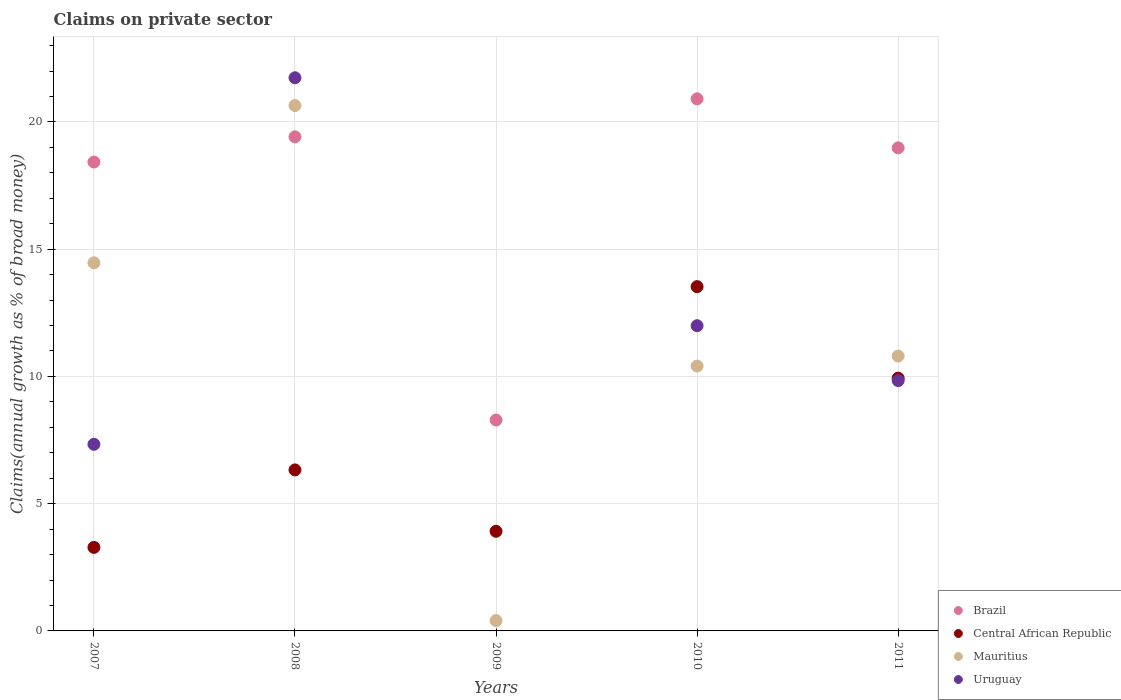Is the number of dotlines equal to the number of legend labels?
Offer a terse response. No. What is the percentage of broad money claimed on private sector in Uruguay in 2008?
Provide a short and direct response. 21.74. Across all years, what is the maximum percentage of broad money claimed on private sector in Mauritius?
Your response must be concise. 20.65. Across all years, what is the minimum percentage of broad money claimed on private sector in Brazil?
Provide a short and direct response. 8.29. In which year was the percentage of broad money claimed on private sector in Central African Republic maximum?
Provide a succinct answer. 2010. What is the total percentage of broad money claimed on private sector in Central African Republic in the graph?
Your response must be concise. 36.99. What is the difference between the percentage of broad money claimed on private sector in Uruguay in 2008 and that in 2010?
Offer a terse response. 9.74. What is the difference between the percentage of broad money claimed on private sector in Brazil in 2011 and the percentage of broad money claimed on private sector in Mauritius in 2007?
Provide a succinct answer. 4.52. What is the average percentage of broad money claimed on private sector in Brazil per year?
Your response must be concise. 17.2. In the year 2008, what is the difference between the percentage of broad money claimed on private sector in Uruguay and percentage of broad money claimed on private sector in Brazil?
Ensure brevity in your answer.  2.32. In how many years, is the percentage of broad money claimed on private sector in Uruguay greater than 20 %?
Offer a terse response. 1. What is the ratio of the percentage of broad money claimed on private sector in Mauritius in 2008 to that in 2011?
Keep it short and to the point. 1.91. Is the percentage of broad money claimed on private sector in Brazil in 2010 less than that in 2011?
Offer a very short reply. No. Is the difference between the percentage of broad money claimed on private sector in Uruguay in 2007 and 2010 greater than the difference between the percentage of broad money claimed on private sector in Brazil in 2007 and 2010?
Offer a terse response. No. What is the difference between the highest and the second highest percentage of broad money claimed on private sector in Central African Republic?
Your answer should be very brief. 3.6. What is the difference between the highest and the lowest percentage of broad money claimed on private sector in Mauritius?
Ensure brevity in your answer.  20.24. Is it the case that in every year, the sum of the percentage of broad money claimed on private sector in Uruguay and percentage of broad money claimed on private sector in Central African Republic  is greater than the sum of percentage of broad money claimed on private sector in Mauritius and percentage of broad money claimed on private sector in Brazil?
Ensure brevity in your answer.  No. Is it the case that in every year, the sum of the percentage of broad money claimed on private sector in Uruguay and percentage of broad money claimed on private sector in Mauritius  is greater than the percentage of broad money claimed on private sector in Central African Republic?
Offer a terse response. No. Is the percentage of broad money claimed on private sector in Mauritius strictly less than the percentage of broad money claimed on private sector in Central African Republic over the years?
Make the answer very short. No. How many years are there in the graph?
Provide a short and direct response. 5. What is the difference between two consecutive major ticks on the Y-axis?
Keep it short and to the point. 5. Where does the legend appear in the graph?
Provide a short and direct response. Bottom right. What is the title of the graph?
Give a very brief answer. Claims on private sector. Does "Ukraine" appear as one of the legend labels in the graph?
Offer a very short reply. No. What is the label or title of the Y-axis?
Offer a terse response. Claims(annual growth as % of broad money). What is the Claims(annual growth as % of broad money) in Brazil in 2007?
Your answer should be very brief. 18.43. What is the Claims(annual growth as % of broad money) of Central African Republic in 2007?
Your response must be concise. 3.28. What is the Claims(annual growth as % of broad money) of Mauritius in 2007?
Provide a succinct answer. 14.47. What is the Claims(annual growth as % of broad money) of Uruguay in 2007?
Your answer should be very brief. 7.33. What is the Claims(annual growth as % of broad money) of Brazil in 2008?
Your response must be concise. 19.42. What is the Claims(annual growth as % of broad money) of Central African Republic in 2008?
Provide a succinct answer. 6.33. What is the Claims(annual growth as % of broad money) in Mauritius in 2008?
Keep it short and to the point. 20.65. What is the Claims(annual growth as % of broad money) in Uruguay in 2008?
Your response must be concise. 21.74. What is the Claims(annual growth as % of broad money) of Brazil in 2009?
Your answer should be compact. 8.29. What is the Claims(annual growth as % of broad money) in Central African Republic in 2009?
Your answer should be compact. 3.91. What is the Claims(annual growth as % of broad money) of Mauritius in 2009?
Offer a terse response. 0.41. What is the Claims(annual growth as % of broad money) of Uruguay in 2009?
Provide a succinct answer. 0. What is the Claims(annual growth as % of broad money) of Brazil in 2010?
Your answer should be compact. 20.91. What is the Claims(annual growth as % of broad money) in Central African Republic in 2010?
Give a very brief answer. 13.53. What is the Claims(annual growth as % of broad money) in Mauritius in 2010?
Give a very brief answer. 10.41. What is the Claims(annual growth as % of broad money) in Uruguay in 2010?
Your response must be concise. 11.99. What is the Claims(annual growth as % of broad money) of Brazil in 2011?
Your answer should be very brief. 18.98. What is the Claims(annual growth as % of broad money) of Central African Republic in 2011?
Ensure brevity in your answer.  9.93. What is the Claims(annual growth as % of broad money) in Mauritius in 2011?
Make the answer very short. 10.8. What is the Claims(annual growth as % of broad money) in Uruguay in 2011?
Make the answer very short. 9.84. Across all years, what is the maximum Claims(annual growth as % of broad money) in Brazil?
Make the answer very short. 20.91. Across all years, what is the maximum Claims(annual growth as % of broad money) in Central African Republic?
Ensure brevity in your answer.  13.53. Across all years, what is the maximum Claims(annual growth as % of broad money) of Mauritius?
Provide a succinct answer. 20.65. Across all years, what is the maximum Claims(annual growth as % of broad money) in Uruguay?
Ensure brevity in your answer.  21.74. Across all years, what is the minimum Claims(annual growth as % of broad money) in Brazil?
Keep it short and to the point. 8.29. Across all years, what is the minimum Claims(annual growth as % of broad money) in Central African Republic?
Offer a very short reply. 3.28. Across all years, what is the minimum Claims(annual growth as % of broad money) of Mauritius?
Ensure brevity in your answer.  0.41. What is the total Claims(annual growth as % of broad money) of Brazil in the graph?
Make the answer very short. 86.02. What is the total Claims(annual growth as % of broad money) in Central African Republic in the graph?
Your answer should be compact. 36.99. What is the total Claims(annual growth as % of broad money) of Mauritius in the graph?
Provide a short and direct response. 56.73. What is the total Claims(annual growth as % of broad money) in Uruguay in the graph?
Provide a short and direct response. 50.9. What is the difference between the Claims(annual growth as % of broad money) of Brazil in 2007 and that in 2008?
Provide a succinct answer. -0.99. What is the difference between the Claims(annual growth as % of broad money) of Central African Republic in 2007 and that in 2008?
Your answer should be compact. -3.04. What is the difference between the Claims(annual growth as % of broad money) of Mauritius in 2007 and that in 2008?
Provide a succinct answer. -6.18. What is the difference between the Claims(annual growth as % of broad money) of Uruguay in 2007 and that in 2008?
Provide a short and direct response. -14.4. What is the difference between the Claims(annual growth as % of broad money) of Brazil in 2007 and that in 2009?
Offer a terse response. 10.14. What is the difference between the Claims(annual growth as % of broad money) of Central African Republic in 2007 and that in 2009?
Keep it short and to the point. -0.63. What is the difference between the Claims(annual growth as % of broad money) of Mauritius in 2007 and that in 2009?
Provide a succinct answer. 14.06. What is the difference between the Claims(annual growth as % of broad money) in Brazil in 2007 and that in 2010?
Offer a very short reply. -2.48. What is the difference between the Claims(annual growth as % of broad money) of Central African Republic in 2007 and that in 2010?
Give a very brief answer. -10.25. What is the difference between the Claims(annual growth as % of broad money) of Mauritius in 2007 and that in 2010?
Give a very brief answer. 4.06. What is the difference between the Claims(annual growth as % of broad money) of Uruguay in 2007 and that in 2010?
Keep it short and to the point. -4.66. What is the difference between the Claims(annual growth as % of broad money) in Brazil in 2007 and that in 2011?
Your answer should be compact. -0.56. What is the difference between the Claims(annual growth as % of broad money) in Central African Republic in 2007 and that in 2011?
Ensure brevity in your answer.  -6.65. What is the difference between the Claims(annual growth as % of broad money) of Mauritius in 2007 and that in 2011?
Your response must be concise. 3.67. What is the difference between the Claims(annual growth as % of broad money) in Uruguay in 2007 and that in 2011?
Your response must be concise. -2.5. What is the difference between the Claims(annual growth as % of broad money) of Brazil in 2008 and that in 2009?
Keep it short and to the point. 11.13. What is the difference between the Claims(annual growth as % of broad money) of Central African Republic in 2008 and that in 2009?
Provide a succinct answer. 2.41. What is the difference between the Claims(annual growth as % of broad money) of Mauritius in 2008 and that in 2009?
Your response must be concise. 20.24. What is the difference between the Claims(annual growth as % of broad money) of Brazil in 2008 and that in 2010?
Offer a terse response. -1.49. What is the difference between the Claims(annual growth as % of broad money) of Central African Republic in 2008 and that in 2010?
Your answer should be very brief. -7.2. What is the difference between the Claims(annual growth as % of broad money) in Mauritius in 2008 and that in 2010?
Keep it short and to the point. 10.24. What is the difference between the Claims(annual growth as % of broad money) of Uruguay in 2008 and that in 2010?
Offer a terse response. 9.74. What is the difference between the Claims(annual growth as % of broad money) of Brazil in 2008 and that in 2011?
Ensure brevity in your answer.  0.43. What is the difference between the Claims(annual growth as % of broad money) in Central African Republic in 2008 and that in 2011?
Your response must be concise. -3.61. What is the difference between the Claims(annual growth as % of broad money) in Mauritius in 2008 and that in 2011?
Make the answer very short. 9.84. What is the difference between the Claims(annual growth as % of broad money) of Uruguay in 2008 and that in 2011?
Offer a very short reply. 11.9. What is the difference between the Claims(annual growth as % of broad money) of Brazil in 2009 and that in 2010?
Ensure brevity in your answer.  -12.62. What is the difference between the Claims(annual growth as % of broad money) of Central African Republic in 2009 and that in 2010?
Provide a short and direct response. -9.61. What is the difference between the Claims(annual growth as % of broad money) of Mauritius in 2009 and that in 2010?
Your response must be concise. -10. What is the difference between the Claims(annual growth as % of broad money) in Brazil in 2009 and that in 2011?
Give a very brief answer. -10.69. What is the difference between the Claims(annual growth as % of broad money) of Central African Republic in 2009 and that in 2011?
Make the answer very short. -6.02. What is the difference between the Claims(annual growth as % of broad money) of Mauritius in 2009 and that in 2011?
Provide a succinct answer. -10.39. What is the difference between the Claims(annual growth as % of broad money) of Brazil in 2010 and that in 2011?
Keep it short and to the point. 1.93. What is the difference between the Claims(annual growth as % of broad money) of Central African Republic in 2010 and that in 2011?
Provide a short and direct response. 3.6. What is the difference between the Claims(annual growth as % of broad money) of Mauritius in 2010 and that in 2011?
Offer a terse response. -0.39. What is the difference between the Claims(annual growth as % of broad money) of Uruguay in 2010 and that in 2011?
Offer a very short reply. 2.16. What is the difference between the Claims(annual growth as % of broad money) in Brazil in 2007 and the Claims(annual growth as % of broad money) in Central African Republic in 2008?
Your response must be concise. 12.1. What is the difference between the Claims(annual growth as % of broad money) in Brazil in 2007 and the Claims(annual growth as % of broad money) in Mauritius in 2008?
Make the answer very short. -2.22. What is the difference between the Claims(annual growth as % of broad money) in Brazil in 2007 and the Claims(annual growth as % of broad money) in Uruguay in 2008?
Ensure brevity in your answer.  -3.31. What is the difference between the Claims(annual growth as % of broad money) in Central African Republic in 2007 and the Claims(annual growth as % of broad money) in Mauritius in 2008?
Your answer should be very brief. -17.36. What is the difference between the Claims(annual growth as % of broad money) of Central African Republic in 2007 and the Claims(annual growth as % of broad money) of Uruguay in 2008?
Keep it short and to the point. -18.45. What is the difference between the Claims(annual growth as % of broad money) of Mauritius in 2007 and the Claims(annual growth as % of broad money) of Uruguay in 2008?
Your answer should be very brief. -7.27. What is the difference between the Claims(annual growth as % of broad money) in Brazil in 2007 and the Claims(annual growth as % of broad money) in Central African Republic in 2009?
Keep it short and to the point. 14.51. What is the difference between the Claims(annual growth as % of broad money) of Brazil in 2007 and the Claims(annual growth as % of broad money) of Mauritius in 2009?
Your answer should be very brief. 18.02. What is the difference between the Claims(annual growth as % of broad money) in Central African Republic in 2007 and the Claims(annual growth as % of broad money) in Mauritius in 2009?
Offer a terse response. 2.88. What is the difference between the Claims(annual growth as % of broad money) in Brazil in 2007 and the Claims(annual growth as % of broad money) in Central African Republic in 2010?
Offer a terse response. 4.9. What is the difference between the Claims(annual growth as % of broad money) in Brazil in 2007 and the Claims(annual growth as % of broad money) in Mauritius in 2010?
Offer a terse response. 8.02. What is the difference between the Claims(annual growth as % of broad money) of Brazil in 2007 and the Claims(annual growth as % of broad money) of Uruguay in 2010?
Offer a terse response. 6.43. What is the difference between the Claims(annual growth as % of broad money) of Central African Republic in 2007 and the Claims(annual growth as % of broad money) of Mauritius in 2010?
Provide a short and direct response. -7.12. What is the difference between the Claims(annual growth as % of broad money) of Central African Republic in 2007 and the Claims(annual growth as % of broad money) of Uruguay in 2010?
Provide a short and direct response. -8.71. What is the difference between the Claims(annual growth as % of broad money) in Mauritius in 2007 and the Claims(annual growth as % of broad money) in Uruguay in 2010?
Provide a succinct answer. 2.47. What is the difference between the Claims(annual growth as % of broad money) in Brazil in 2007 and the Claims(annual growth as % of broad money) in Central African Republic in 2011?
Provide a short and direct response. 8.49. What is the difference between the Claims(annual growth as % of broad money) of Brazil in 2007 and the Claims(annual growth as % of broad money) of Mauritius in 2011?
Keep it short and to the point. 7.62. What is the difference between the Claims(annual growth as % of broad money) in Brazil in 2007 and the Claims(annual growth as % of broad money) in Uruguay in 2011?
Offer a terse response. 8.59. What is the difference between the Claims(annual growth as % of broad money) in Central African Republic in 2007 and the Claims(annual growth as % of broad money) in Mauritius in 2011?
Make the answer very short. -7.52. What is the difference between the Claims(annual growth as % of broad money) in Central African Republic in 2007 and the Claims(annual growth as % of broad money) in Uruguay in 2011?
Your answer should be compact. -6.55. What is the difference between the Claims(annual growth as % of broad money) of Mauritius in 2007 and the Claims(annual growth as % of broad money) of Uruguay in 2011?
Your response must be concise. 4.63. What is the difference between the Claims(annual growth as % of broad money) of Brazil in 2008 and the Claims(annual growth as % of broad money) of Central African Republic in 2009?
Your response must be concise. 15.5. What is the difference between the Claims(annual growth as % of broad money) in Brazil in 2008 and the Claims(annual growth as % of broad money) in Mauritius in 2009?
Your answer should be compact. 19.01. What is the difference between the Claims(annual growth as % of broad money) of Central African Republic in 2008 and the Claims(annual growth as % of broad money) of Mauritius in 2009?
Offer a terse response. 5.92. What is the difference between the Claims(annual growth as % of broad money) in Brazil in 2008 and the Claims(annual growth as % of broad money) in Central African Republic in 2010?
Offer a terse response. 5.89. What is the difference between the Claims(annual growth as % of broad money) in Brazil in 2008 and the Claims(annual growth as % of broad money) in Mauritius in 2010?
Your answer should be very brief. 9.01. What is the difference between the Claims(annual growth as % of broad money) of Brazil in 2008 and the Claims(annual growth as % of broad money) of Uruguay in 2010?
Ensure brevity in your answer.  7.42. What is the difference between the Claims(annual growth as % of broad money) in Central African Republic in 2008 and the Claims(annual growth as % of broad money) in Mauritius in 2010?
Offer a terse response. -4.08. What is the difference between the Claims(annual growth as % of broad money) in Central African Republic in 2008 and the Claims(annual growth as % of broad money) in Uruguay in 2010?
Your response must be concise. -5.67. What is the difference between the Claims(annual growth as % of broad money) of Mauritius in 2008 and the Claims(annual growth as % of broad money) of Uruguay in 2010?
Offer a very short reply. 8.65. What is the difference between the Claims(annual growth as % of broad money) in Brazil in 2008 and the Claims(annual growth as % of broad money) in Central African Republic in 2011?
Offer a terse response. 9.48. What is the difference between the Claims(annual growth as % of broad money) in Brazil in 2008 and the Claims(annual growth as % of broad money) in Mauritius in 2011?
Make the answer very short. 8.62. What is the difference between the Claims(annual growth as % of broad money) in Brazil in 2008 and the Claims(annual growth as % of broad money) in Uruguay in 2011?
Offer a very short reply. 9.58. What is the difference between the Claims(annual growth as % of broad money) in Central African Republic in 2008 and the Claims(annual growth as % of broad money) in Mauritius in 2011?
Make the answer very short. -4.47. What is the difference between the Claims(annual growth as % of broad money) of Central African Republic in 2008 and the Claims(annual growth as % of broad money) of Uruguay in 2011?
Offer a very short reply. -3.51. What is the difference between the Claims(annual growth as % of broad money) of Mauritius in 2008 and the Claims(annual growth as % of broad money) of Uruguay in 2011?
Your answer should be compact. 10.81. What is the difference between the Claims(annual growth as % of broad money) in Brazil in 2009 and the Claims(annual growth as % of broad money) in Central African Republic in 2010?
Ensure brevity in your answer.  -5.24. What is the difference between the Claims(annual growth as % of broad money) in Brazil in 2009 and the Claims(annual growth as % of broad money) in Mauritius in 2010?
Offer a very short reply. -2.12. What is the difference between the Claims(annual growth as % of broad money) of Brazil in 2009 and the Claims(annual growth as % of broad money) of Uruguay in 2010?
Your answer should be very brief. -3.71. What is the difference between the Claims(annual growth as % of broad money) in Central African Republic in 2009 and the Claims(annual growth as % of broad money) in Mauritius in 2010?
Give a very brief answer. -6.49. What is the difference between the Claims(annual growth as % of broad money) in Central African Republic in 2009 and the Claims(annual growth as % of broad money) in Uruguay in 2010?
Your answer should be compact. -8.08. What is the difference between the Claims(annual growth as % of broad money) in Mauritius in 2009 and the Claims(annual growth as % of broad money) in Uruguay in 2010?
Your answer should be compact. -11.59. What is the difference between the Claims(annual growth as % of broad money) of Brazil in 2009 and the Claims(annual growth as % of broad money) of Central African Republic in 2011?
Provide a succinct answer. -1.65. What is the difference between the Claims(annual growth as % of broad money) in Brazil in 2009 and the Claims(annual growth as % of broad money) in Mauritius in 2011?
Your answer should be compact. -2.51. What is the difference between the Claims(annual growth as % of broad money) in Brazil in 2009 and the Claims(annual growth as % of broad money) in Uruguay in 2011?
Make the answer very short. -1.55. What is the difference between the Claims(annual growth as % of broad money) of Central African Republic in 2009 and the Claims(annual growth as % of broad money) of Mauritius in 2011?
Offer a very short reply. -6.89. What is the difference between the Claims(annual growth as % of broad money) in Central African Republic in 2009 and the Claims(annual growth as % of broad money) in Uruguay in 2011?
Provide a succinct answer. -5.92. What is the difference between the Claims(annual growth as % of broad money) in Mauritius in 2009 and the Claims(annual growth as % of broad money) in Uruguay in 2011?
Your answer should be compact. -9.43. What is the difference between the Claims(annual growth as % of broad money) of Brazil in 2010 and the Claims(annual growth as % of broad money) of Central African Republic in 2011?
Your answer should be compact. 10.98. What is the difference between the Claims(annual growth as % of broad money) of Brazil in 2010 and the Claims(annual growth as % of broad money) of Mauritius in 2011?
Ensure brevity in your answer.  10.11. What is the difference between the Claims(annual growth as % of broad money) of Brazil in 2010 and the Claims(annual growth as % of broad money) of Uruguay in 2011?
Offer a terse response. 11.07. What is the difference between the Claims(annual growth as % of broad money) of Central African Republic in 2010 and the Claims(annual growth as % of broad money) of Mauritius in 2011?
Provide a short and direct response. 2.73. What is the difference between the Claims(annual growth as % of broad money) of Central African Republic in 2010 and the Claims(annual growth as % of broad money) of Uruguay in 2011?
Provide a succinct answer. 3.69. What is the difference between the Claims(annual growth as % of broad money) in Mauritius in 2010 and the Claims(annual growth as % of broad money) in Uruguay in 2011?
Make the answer very short. 0.57. What is the average Claims(annual growth as % of broad money) of Brazil per year?
Your answer should be compact. 17.2. What is the average Claims(annual growth as % of broad money) of Central African Republic per year?
Keep it short and to the point. 7.4. What is the average Claims(annual growth as % of broad money) of Mauritius per year?
Keep it short and to the point. 11.35. What is the average Claims(annual growth as % of broad money) in Uruguay per year?
Ensure brevity in your answer.  10.18. In the year 2007, what is the difference between the Claims(annual growth as % of broad money) in Brazil and Claims(annual growth as % of broad money) in Central African Republic?
Make the answer very short. 15.14. In the year 2007, what is the difference between the Claims(annual growth as % of broad money) of Brazil and Claims(annual growth as % of broad money) of Mauritius?
Provide a short and direct response. 3.96. In the year 2007, what is the difference between the Claims(annual growth as % of broad money) of Brazil and Claims(annual growth as % of broad money) of Uruguay?
Your response must be concise. 11.09. In the year 2007, what is the difference between the Claims(annual growth as % of broad money) of Central African Republic and Claims(annual growth as % of broad money) of Mauritius?
Keep it short and to the point. -11.18. In the year 2007, what is the difference between the Claims(annual growth as % of broad money) in Central African Republic and Claims(annual growth as % of broad money) in Uruguay?
Make the answer very short. -4.05. In the year 2007, what is the difference between the Claims(annual growth as % of broad money) of Mauritius and Claims(annual growth as % of broad money) of Uruguay?
Provide a succinct answer. 7.13. In the year 2008, what is the difference between the Claims(annual growth as % of broad money) in Brazil and Claims(annual growth as % of broad money) in Central African Republic?
Offer a very short reply. 13.09. In the year 2008, what is the difference between the Claims(annual growth as % of broad money) in Brazil and Claims(annual growth as % of broad money) in Mauritius?
Provide a short and direct response. -1.23. In the year 2008, what is the difference between the Claims(annual growth as % of broad money) in Brazil and Claims(annual growth as % of broad money) in Uruguay?
Ensure brevity in your answer.  -2.32. In the year 2008, what is the difference between the Claims(annual growth as % of broad money) of Central African Republic and Claims(annual growth as % of broad money) of Mauritius?
Give a very brief answer. -14.32. In the year 2008, what is the difference between the Claims(annual growth as % of broad money) in Central African Republic and Claims(annual growth as % of broad money) in Uruguay?
Your response must be concise. -15.41. In the year 2008, what is the difference between the Claims(annual growth as % of broad money) in Mauritius and Claims(annual growth as % of broad money) in Uruguay?
Offer a terse response. -1.09. In the year 2009, what is the difference between the Claims(annual growth as % of broad money) of Brazil and Claims(annual growth as % of broad money) of Central African Republic?
Give a very brief answer. 4.37. In the year 2009, what is the difference between the Claims(annual growth as % of broad money) of Brazil and Claims(annual growth as % of broad money) of Mauritius?
Ensure brevity in your answer.  7.88. In the year 2009, what is the difference between the Claims(annual growth as % of broad money) in Central African Republic and Claims(annual growth as % of broad money) in Mauritius?
Your response must be concise. 3.51. In the year 2010, what is the difference between the Claims(annual growth as % of broad money) of Brazil and Claims(annual growth as % of broad money) of Central African Republic?
Provide a short and direct response. 7.38. In the year 2010, what is the difference between the Claims(annual growth as % of broad money) in Brazil and Claims(annual growth as % of broad money) in Mauritius?
Ensure brevity in your answer.  10.5. In the year 2010, what is the difference between the Claims(annual growth as % of broad money) of Brazil and Claims(annual growth as % of broad money) of Uruguay?
Provide a succinct answer. 8.92. In the year 2010, what is the difference between the Claims(annual growth as % of broad money) of Central African Republic and Claims(annual growth as % of broad money) of Mauritius?
Provide a succinct answer. 3.12. In the year 2010, what is the difference between the Claims(annual growth as % of broad money) of Central African Republic and Claims(annual growth as % of broad money) of Uruguay?
Offer a very short reply. 1.54. In the year 2010, what is the difference between the Claims(annual growth as % of broad money) in Mauritius and Claims(annual growth as % of broad money) in Uruguay?
Provide a short and direct response. -1.58. In the year 2011, what is the difference between the Claims(annual growth as % of broad money) of Brazil and Claims(annual growth as % of broad money) of Central African Republic?
Offer a very short reply. 9.05. In the year 2011, what is the difference between the Claims(annual growth as % of broad money) in Brazil and Claims(annual growth as % of broad money) in Mauritius?
Provide a succinct answer. 8.18. In the year 2011, what is the difference between the Claims(annual growth as % of broad money) in Brazil and Claims(annual growth as % of broad money) in Uruguay?
Your answer should be very brief. 9.14. In the year 2011, what is the difference between the Claims(annual growth as % of broad money) of Central African Republic and Claims(annual growth as % of broad money) of Mauritius?
Keep it short and to the point. -0.87. In the year 2011, what is the difference between the Claims(annual growth as % of broad money) in Central African Republic and Claims(annual growth as % of broad money) in Uruguay?
Ensure brevity in your answer.  0.1. In the year 2011, what is the difference between the Claims(annual growth as % of broad money) in Mauritius and Claims(annual growth as % of broad money) in Uruguay?
Your answer should be compact. 0.96. What is the ratio of the Claims(annual growth as % of broad money) of Brazil in 2007 to that in 2008?
Offer a very short reply. 0.95. What is the ratio of the Claims(annual growth as % of broad money) in Central African Republic in 2007 to that in 2008?
Keep it short and to the point. 0.52. What is the ratio of the Claims(annual growth as % of broad money) of Mauritius in 2007 to that in 2008?
Provide a succinct answer. 0.7. What is the ratio of the Claims(annual growth as % of broad money) of Uruguay in 2007 to that in 2008?
Your answer should be compact. 0.34. What is the ratio of the Claims(annual growth as % of broad money) of Brazil in 2007 to that in 2009?
Your answer should be very brief. 2.22. What is the ratio of the Claims(annual growth as % of broad money) in Central African Republic in 2007 to that in 2009?
Ensure brevity in your answer.  0.84. What is the ratio of the Claims(annual growth as % of broad money) in Mauritius in 2007 to that in 2009?
Provide a short and direct response. 35.58. What is the ratio of the Claims(annual growth as % of broad money) in Brazil in 2007 to that in 2010?
Keep it short and to the point. 0.88. What is the ratio of the Claims(annual growth as % of broad money) in Central African Republic in 2007 to that in 2010?
Ensure brevity in your answer.  0.24. What is the ratio of the Claims(annual growth as % of broad money) of Mauritius in 2007 to that in 2010?
Your answer should be very brief. 1.39. What is the ratio of the Claims(annual growth as % of broad money) in Uruguay in 2007 to that in 2010?
Offer a very short reply. 0.61. What is the ratio of the Claims(annual growth as % of broad money) in Brazil in 2007 to that in 2011?
Your answer should be compact. 0.97. What is the ratio of the Claims(annual growth as % of broad money) of Central African Republic in 2007 to that in 2011?
Ensure brevity in your answer.  0.33. What is the ratio of the Claims(annual growth as % of broad money) of Mauritius in 2007 to that in 2011?
Ensure brevity in your answer.  1.34. What is the ratio of the Claims(annual growth as % of broad money) of Uruguay in 2007 to that in 2011?
Offer a very short reply. 0.75. What is the ratio of the Claims(annual growth as % of broad money) in Brazil in 2008 to that in 2009?
Offer a terse response. 2.34. What is the ratio of the Claims(annual growth as % of broad money) in Central African Republic in 2008 to that in 2009?
Your answer should be compact. 1.62. What is the ratio of the Claims(annual growth as % of broad money) in Mauritius in 2008 to that in 2009?
Your answer should be very brief. 50.78. What is the ratio of the Claims(annual growth as % of broad money) of Central African Republic in 2008 to that in 2010?
Offer a very short reply. 0.47. What is the ratio of the Claims(annual growth as % of broad money) in Mauritius in 2008 to that in 2010?
Offer a very short reply. 1.98. What is the ratio of the Claims(annual growth as % of broad money) in Uruguay in 2008 to that in 2010?
Offer a very short reply. 1.81. What is the ratio of the Claims(annual growth as % of broad money) in Brazil in 2008 to that in 2011?
Give a very brief answer. 1.02. What is the ratio of the Claims(annual growth as % of broad money) in Central African Republic in 2008 to that in 2011?
Your response must be concise. 0.64. What is the ratio of the Claims(annual growth as % of broad money) in Mauritius in 2008 to that in 2011?
Offer a very short reply. 1.91. What is the ratio of the Claims(annual growth as % of broad money) in Uruguay in 2008 to that in 2011?
Your answer should be very brief. 2.21. What is the ratio of the Claims(annual growth as % of broad money) of Brazil in 2009 to that in 2010?
Make the answer very short. 0.4. What is the ratio of the Claims(annual growth as % of broad money) in Central African Republic in 2009 to that in 2010?
Offer a very short reply. 0.29. What is the ratio of the Claims(annual growth as % of broad money) in Mauritius in 2009 to that in 2010?
Provide a succinct answer. 0.04. What is the ratio of the Claims(annual growth as % of broad money) in Brazil in 2009 to that in 2011?
Your response must be concise. 0.44. What is the ratio of the Claims(annual growth as % of broad money) in Central African Republic in 2009 to that in 2011?
Provide a short and direct response. 0.39. What is the ratio of the Claims(annual growth as % of broad money) of Mauritius in 2009 to that in 2011?
Offer a terse response. 0.04. What is the ratio of the Claims(annual growth as % of broad money) of Brazil in 2010 to that in 2011?
Your answer should be very brief. 1.1. What is the ratio of the Claims(annual growth as % of broad money) of Central African Republic in 2010 to that in 2011?
Offer a very short reply. 1.36. What is the ratio of the Claims(annual growth as % of broad money) in Mauritius in 2010 to that in 2011?
Provide a succinct answer. 0.96. What is the ratio of the Claims(annual growth as % of broad money) of Uruguay in 2010 to that in 2011?
Give a very brief answer. 1.22. What is the difference between the highest and the second highest Claims(annual growth as % of broad money) of Brazil?
Provide a short and direct response. 1.49. What is the difference between the highest and the second highest Claims(annual growth as % of broad money) of Central African Republic?
Keep it short and to the point. 3.6. What is the difference between the highest and the second highest Claims(annual growth as % of broad money) in Mauritius?
Provide a succinct answer. 6.18. What is the difference between the highest and the second highest Claims(annual growth as % of broad money) of Uruguay?
Keep it short and to the point. 9.74. What is the difference between the highest and the lowest Claims(annual growth as % of broad money) of Brazil?
Offer a very short reply. 12.62. What is the difference between the highest and the lowest Claims(annual growth as % of broad money) of Central African Republic?
Offer a terse response. 10.25. What is the difference between the highest and the lowest Claims(annual growth as % of broad money) in Mauritius?
Your response must be concise. 20.24. What is the difference between the highest and the lowest Claims(annual growth as % of broad money) in Uruguay?
Your answer should be compact. 21.74. 